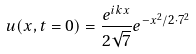Convert formula to latex. <formula><loc_0><loc_0><loc_500><loc_500>u ( x , t = 0 ) = \frac { e ^ { i k x } } { 2 \sqrt { 7 } } e ^ { - x ^ { 2 } / 2 \cdot 7 ^ { 2 } }</formula> 